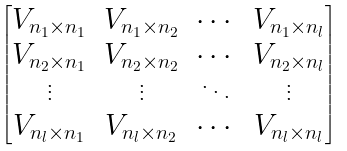<formula> <loc_0><loc_0><loc_500><loc_500>\begin{bmatrix} V _ { n _ { 1 } \times n _ { 1 } } & V _ { n _ { 1 } \times n _ { 2 } } & \cdots & V _ { n _ { 1 } \times n _ { l } } \\ V _ { n _ { 2 } \times n _ { 1 } } & V _ { n _ { 2 } \times n _ { 2 } } & \cdots & V _ { n _ { 2 } \times n _ { l } } \\ \vdots & \vdots & \ddots & \vdots \\ V _ { n _ { l } \times n _ { 1 } } & V _ { n _ { l } \times n _ { 2 } } & \cdots & V _ { n _ { l } \times n _ { l } } \end{bmatrix}</formula> 